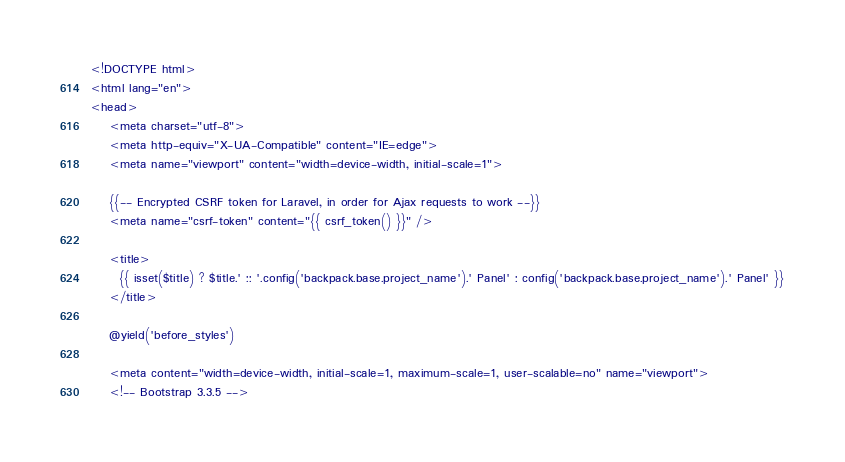<code> <loc_0><loc_0><loc_500><loc_500><_PHP_><!DOCTYPE html>
<html lang="en">
<head>
    <meta charset="utf-8">
    <meta http-equiv="X-UA-Compatible" content="IE=edge">
    <meta name="viewport" content="width=device-width, initial-scale=1">

    {{-- Encrypted CSRF token for Laravel, in order for Ajax requests to work --}}
    <meta name="csrf-token" content="{{ csrf_token() }}" />

    <title>
      {{ isset($title) ? $title.' :: '.config('backpack.base.project_name').' Panel' : config('backpack.base.project_name').' Panel' }}
    </title>

    @yield('before_styles')

    <meta content="width=device-width, initial-scale=1, maximum-scale=1, user-scalable=no" name="viewport">
    <!-- Bootstrap 3.3.5 --></code> 